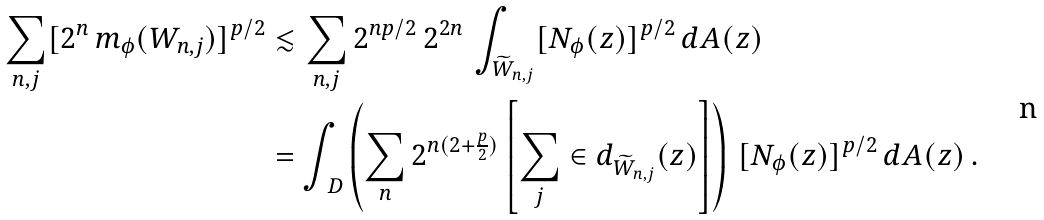<formula> <loc_0><loc_0><loc_500><loc_500>\sum _ { n , j } [ 2 ^ { n } \, m _ { \phi } ( W _ { n , j } ) ] ^ { p / 2 } & \lesssim \sum _ { n , j } 2 ^ { n p / 2 } \, 2 ^ { 2 n } \, \int _ { \widetilde { W } _ { n , j } } [ N _ { \phi } ( z ) ] ^ { p / 2 } \, d A ( z ) \\ & = \int _ { \ D } \left ( \sum _ { n } 2 ^ { n ( 2 + \frac { p } { 2 } ) } \left [ \sum _ { j } \in d _ { \widetilde { W } _ { n , j } } ( z ) \right ] \right ) \, [ N _ { \phi } ( z ) ] ^ { p / 2 } \, d A ( z ) \, .</formula> 